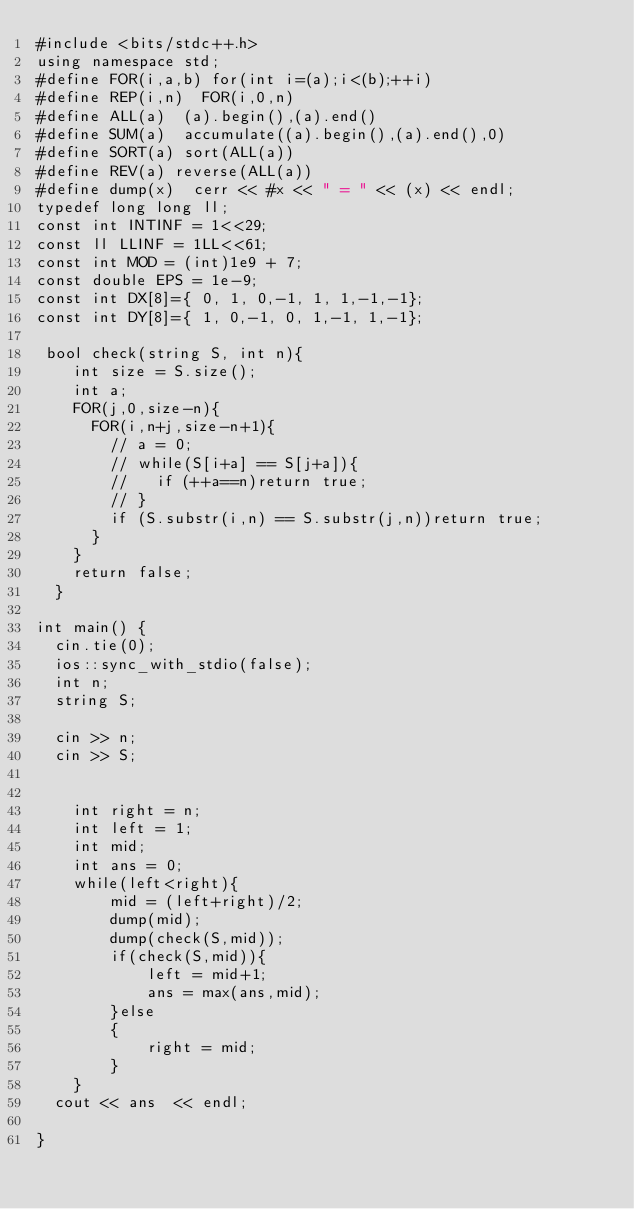<code> <loc_0><loc_0><loc_500><loc_500><_C++_>#include <bits/stdc++.h>
using namespace std;
#define FOR(i,a,b) for(int i=(a);i<(b);++i)
#define REP(i,n)  FOR(i,0,n)
#define ALL(a)  (a).begin(),(a).end()
#define SUM(a)  accumulate((a).begin(),(a).end(),0)
#define SORT(a) sort(ALL(a))
#define REV(a) reverse(ALL(a))
#define dump(x)  cerr << #x << " = " << (x) << endl;
typedef long long ll;
const int INTINF = 1<<29;
const ll LLINF = 1LL<<61;
const int MOD = (int)1e9 + 7;
const double EPS = 1e-9;
const int DX[8]={ 0, 1, 0,-1, 1, 1,-1,-1};
const int DY[8]={ 1, 0,-1, 0, 1,-1, 1,-1};

 bool check(string S, int n){
    int size = S.size();    
    int a;
    FOR(j,0,size-n){
      FOR(i,n+j,size-n+1){
        // a = 0;
        // while(S[i+a] == S[j+a]){
        //   if (++a==n)return true;
        // }
        if (S.substr(i,n) == S.substr(j,n))return true;
      }
    }
    return false;
  }

int main() {
  cin.tie(0);
  ios::sync_with_stdio(false);
  int n;
  string S;
  
  cin >> n;
  cin >> S;
  

    int right = n;
    int left = 1;
    int mid;
    int ans = 0;
    while(left<right){
        mid = (left+right)/2;
        dump(mid);
        dump(check(S,mid));
        if(check(S,mid)){
            left = mid+1;
            ans = max(ans,mid);
        }else
        {
            right = mid;
        }
    }
  cout << ans  << endl;

}
</code> 